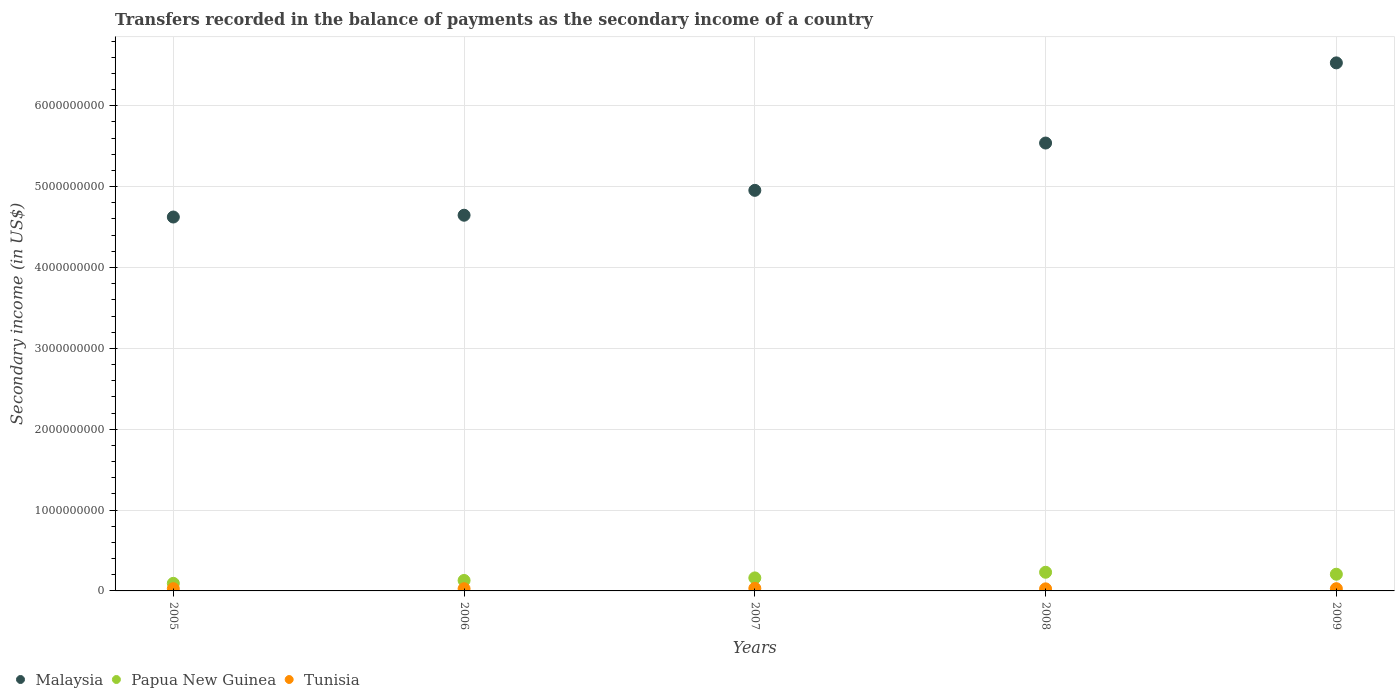How many different coloured dotlines are there?
Ensure brevity in your answer.  3. What is the secondary income of in Papua New Guinea in 2009?
Your answer should be very brief. 2.06e+08. Across all years, what is the maximum secondary income of in Malaysia?
Ensure brevity in your answer.  6.53e+09. Across all years, what is the minimum secondary income of in Malaysia?
Ensure brevity in your answer.  4.62e+09. What is the total secondary income of in Papua New Guinea in the graph?
Make the answer very short. 8.21e+08. What is the difference between the secondary income of in Papua New Guinea in 2006 and that in 2008?
Ensure brevity in your answer.  -1.01e+08. What is the difference between the secondary income of in Malaysia in 2005 and the secondary income of in Tunisia in 2009?
Your answer should be compact. 4.60e+09. What is the average secondary income of in Tunisia per year?
Your response must be concise. 2.79e+07. In the year 2005, what is the difference between the secondary income of in Malaysia and secondary income of in Papua New Guinea?
Your answer should be compact. 4.53e+09. What is the ratio of the secondary income of in Tunisia in 2005 to that in 2009?
Provide a short and direct response. 1. Is the secondary income of in Malaysia in 2006 less than that in 2008?
Give a very brief answer. Yes. Is the difference between the secondary income of in Malaysia in 2008 and 2009 greater than the difference between the secondary income of in Papua New Guinea in 2008 and 2009?
Make the answer very short. No. What is the difference between the highest and the second highest secondary income of in Malaysia?
Offer a very short reply. 9.91e+08. What is the difference between the highest and the lowest secondary income of in Tunisia?
Keep it short and to the point. 5.80e+06. Is the secondary income of in Tunisia strictly greater than the secondary income of in Malaysia over the years?
Keep it short and to the point. No. How many years are there in the graph?
Your answer should be compact. 5. Where does the legend appear in the graph?
Your answer should be very brief. Bottom left. How many legend labels are there?
Offer a terse response. 3. How are the legend labels stacked?
Provide a succinct answer. Horizontal. What is the title of the graph?
Provide a succinct answer. Transfers recorded in the balance of payments as the secondary income of a country. What is the label or title of the Y-axis?
Your response must be concise. Secondary income (in US$). What is the Secondary income (in US$) in Malaysia in 2005?
Offer a terse response. 4.62e+09. What is the Secondary income (in US$) of Papua New Guinea in 2005?
Give a very brief answer. 9.36e+07. What is the Secondary income (in US$) of Tunisia in 2005?
Offer a very short reply. 2.77e+07. What is the Secondary income (in US$) of Malaysia in 2006?
Provide a short and direct response. 4.65e+09. What is the Secondary income (in US$) of Papua New Guinea in 2006?
Offer a very short reply. 1.29e+08. What is the Secondary income (in US$) of Tunisia in 2006?
Provide a succinct answer. 2.70e+07. What is the Secondary income (in US$) of Malaysia in 2007?
Make the answer very short. 4.95e+09. What is the Secondary income (in US$) of Papua New Guinea in 2007?
Your answer should be compact. 1.61e+08. What is the Secondary income (in US$) in Tunisia in 2007?
Your answer should be very brief. 3.15e+07. What is the Secondary income (in US$) of Malaysia in 2008?
Ensure brevity in your answer.  5.54e+09. What is the Secondary income (in US$) of Papua New Guinea in 2008?
Provide a succinct answer. 2.31e+08. What is the Secondary income (in US$) of Tunisia in 2008?
Offer a terse response. 2.57e+07. What is the Secondary income (in US$) of Malaysia in 2009?
Your response must be concise. 6.53e+09. What is the Secondary income (in US$) in Papua New Guinea in 2009?
Keep it short and to the point. 2.06e+08. What is the Secondary income (in US$) in Tunisia in 2009?
Make the answer very short. 2.75e+07. Across all years, what is the maximum Secondary income (in US$) of Malaysia?
Your answer should be compact. 6.53e+09. Across all years, what is the maximum Secondary income (in US$) in Papua New Guinea?
Provide a short and direct response. 2.31e+08. Across all years, what is the maximum Secondary income (in US$) in Tunisia?
Provide a succinct answer. 3.15e+07. Across all years, what is the minimum Secondary income (in US$) in Malaysia?
Offer a very short reply. 4.62e+09. Across all years, what is the minimum Secondary income (in US$) of Papua New Guinea?
Your answer should be very brief. 9.36e+07. Across all years, what is the minimum Secondary income (in US$) in Tunisia?
Your response must be concise. 2.57e+07. What is the total Secondary income (in US$) of Malaysia in the graph?
Keep it short and to the point. 2.63e+1. What is the total Secondary income (in US$) in Papua New Guinea in the graph?
Ensure brevity in your answer.  8.21e+08. What is the total Secondary income (in US$) in Tunisia in the graph?
Give a very brief answer. 1.40e+08. What is the difference between the Secondary income (in US$) of Malaysia in 2005 and that in 2006?
Keep it short and to the point. -2.22e+07. What is the difference between the Secondary income (in US$) in Papua New Guinea in 2005 and that in 2006?
Offer a very short reply. -3.58e+07. What is the difference between the Secondary income (in US$) of Tunisia in 2005 and that in 2006?
Keep it short and to the point. 6.23e+05. What is the difference between the Secondary income (in US$) of Malaysia in 2005 and that in 2007?
Provide a succinct answer. -3.30e+08. What is the difference between the Secondary income (in US$) of Papua New Guinea in 2005 and that in 2007?
Provide a succinct answer. -6.73e+07. What is the difference between the Secondary income (in US$) in Tunisia in 2005 and that in 2007?
Make the answer very short. -3.86e+06. What is the difference between the Secondary income (in US$) of Malaysia in 2005 and that in 2008?
Ensure brevity in your answer.  -9.15e+08. What is the difference between the Secondary income (in US$) of Papua New Guinea in 2005 and that in 2008?
Your response must be concise. -1.37e+08. What is the difference between the Secondary income (in US$) in Tunisia in 2005 and that in 2008?
Make the answer very short. 1.94e+06. What is the difference between the Secondary income (in US$) of Malaysia in 2005 and that in 2009?
Your answer should be very brief. -1.91e+09. What is the difference between the Secondary income (in US$) of Papua New Guinea in 2005 and that in 2009?
Keep it short and to the point. -1.13e+08. What is the difference between the Secondary income (in US$) in Tunisia in 2005 and that in 2009?
Your answer should be very brief. 1.20e+05. What is the difference between the Secondary income (in US$) of Malaysia in 2006 and that in 2007?
Offer a very short reply. -3.08e+08. What is the difference between the Secondary income (in US$) of Papua New Guinea in 2006 and that in 2007?
Keep it short and to the point. -3.15e+07. What is the difference between the Secondary income (in US$) in Tunisia in 2006 and that in 2007?
Keep it short and to the point. -4.48e+06. What is the difference between the Secondary income (in US$) in Malaysia in 2006 and that in 2008?
Keep it short and to the point. -8.93e+08. What is the difference between the Secondary income (in US$) of Papua New Guinea in 2006 and that in 2008?
Your answer should be very brief. -1.01e+08. What is the difference between the Secondary income (in US$) of Tunisia in 2006 and that in 2008?
Provide a succinct answer. 1.32e+06. What is the difference between the Secondary income (in US$) in Malaysia in 2006 and that in 2009?
Offer a terse response. -1.88e+09. What is the difference between the Secondary income (in US$) of Papua New Guinea in 2006 and that in 2009?
Offer a terse response. -7.71e+07. What is the difference between the Secondary income (in US$) in Tunisia in 2006 and that in 2009?
Ensure brevity in your answer.  -5.03e+05. What is the difference between the Secondary income (in US$) of Malaysia in 2007 and that in 2008?
Keep it short and to the point. -5.85e+08. What is the difference between the Secondary income (in US$) in Papua New Guinea in 2007 and that in 2008?
Your answer should be very brief. -7.00e+07. What is the difference between the Secondary income (in US$) of Tunisia in 2007 and that in 2008?
Your answer should be compact. 5.80e+06. What is the difference between the Secondary income (in US$) in Malaysia in 2007 and that in 2009?
Keep it short and to the point. -1.58e+09. What is the difference between the Secondary income (in US$) of Papua New Guinea in 2007 and that in 2009?
Give a very brief answer. -4.56e+07. What is the difference between the Secondary income (in US$) of Tunisia in 2007 and that in 2009?
Give a very brief answer. 3.98e+06. What is the difference between the Secondary income (in US$) of Malaysia in 2008 and that in 2009?
Provide a succinct answer. -9.91e+08. What is the difference between the Secondary income (in US$) of Papua New Guinea in 2008 and that in 2009?
Offer a very short reply. 2.44e+07. What is the difference between the Secondary income (in US$) of Tunisia in 2008 and that in 2009?
Your answer should be compact. -1.82e+06. What is the difference between the Secondary income (in US$) in Malaysia in 2005 and the Secondary income (in US$) in Papua New Guinea in 2006?
Keep it short and to the point. 4.49e+09. What is the difference between the Secondary income (in US$) in Malaysia in 2005 and the Secondary income (in US$) in Tunisia in 2006?
Offer a terse response. 4.60e+09. What is the difference between the Secondary income (in US$) in Papua New Guinea in 2005 and the Secondary income (in US$) in Tunisia in 2006?
Offer a very short reply. 6.65e+07. What is the difference between the Secondary income (in US$) in Malaysia in 2005 and the Secondary income (in US$) in Papua New Guinea in 2007?
Offer a very short reply. 4.46e+09. What is the difference between the Secondary income (in US$) of Malaysia in 2005 and the Secondary income (in US$) of Tunisia in 2007?
Keep it short and to the point. 4.59e+09. What is the difference between the Secondary income (in US$) in Papua New Guinea in 2005 and the Secondary income (in US$) in Tunisia in 2007?
Offer a terse response. 6.21e+07. What is the difference between the Secondary income (in US$) in Malaysia in 2005 and the Secondary income (in US$) in Papua New Guinea in 2008?
Offer a very short reply. 4.39e+09. What is the difference between the Secondary income (in US$) in Malaysia in 2005 and the Secondary income (in US$) in Tunisia in 2008?
Offer a very short reply. 4.60e+09. What is the difference between the Secondary income (in US$) in Papua New Guinea in 2005 and the Secondary income (in US$) in Tunisia in 2008?
Give a very brief answer. 6.79e+07. What is the difference between the Secondary income (in US$) in Malaysia in 2005 and the Secondary income (in US$) in Papua New Guinea in 2009?
Your answer should be compact. 4.42e+09. What is the difference between the Secondary income (in US$) of Malaysia in 2005 and the Secondary income (in US$) of Tunisia in 2009?
Your answer should be very brief. 4.60e+09. What is the difference between the Secondary income (in US$) of Papua New Guinea in 2005 and the Secondary income (in US$) of Tunisia in 2009?
Offer a terse response. 6.60e+07. What is the difference between the Secondary income (in US$) of Malaysia in 2006 and the Secondary income (in US$) of Papua New Guinea in 2007?
Give a very brief answer. 4.49e+09. What is the difference between the Secondary income (in US$) in Malaysia in 2006 and the Secondary income (in US$) in Tunisia in 2007?
Give a very brief answer. 4.61e+09. What is the difference between the Secondary income (in US$) of Papua New Guinea in 2006 and the Secondary income (in US$) of Tunisia in 2007?
Offer a terse response. 9.79e+07. What is the difference between the Secondary income (in US$) in Malaysia in 2006 and the Secondary income (in US$) in Papua New Guinea in 2008?
Provide a short and direct response. 4.42e+09. What is the difference between the Secondary income (in US$) in Malaysia in 2006 and the Secondary income (in US$) in Tunisia in 2008?
Offer a terse response. 4.62e+09. What is the difference between the Secondary income (in US$) in Papua New Guinea in 2006 and the Secondary income (in US$) in Tunisia in 2008?
Keep it short and to the point. 1.04e+08. What is the difference between the Secondary income (in US$) in Malaysia in 2006 and the Secondary income (in US$) in Papua New Guinea in 2009?
Your answer should be very brief. 4.44e+09. What is the difference between the Secondary income (in US$) in Malaysia in 2006 and the Secondary income (in US$) in Tunisia in 2009?
Your answer should be compact. 4.62e+09. What is the difference between the Secondary income (in US$) in Papua New Guinea in 2006 and the Secondary income (in US$) in Tunisia in 2009?
Ensure brevity in your answer.  1.02e+08. What is the difference between the Secondary income (in US$) in Malaysia in 2007 and the Secondary income (in US$) in Papua New Guinea in 2008?
Provide a short and direct response. 4.72e+09. What is the difference between the Secondary income (in US$) in Malaysia in 2007 and the Secondary income (in US$) in Tunisia in 2008?
Offer a terse response. 4.93e+09. What is the difference between the Secondary income (in US$) in Papua New Guinea in 2007 and the Secondary income (in US$) in Tunisia in 2008?
Provide a short and direct response. 1.35e+08. What is the difference between the Secondary income (in US$) of Malaysia in 2007 and the Secondary income (in US$) of Papua New Guinea in 2009?
Your answer should be compact. 4.75e+09. What is the difference between the Secondary income (in US$) of Malaysia in 2007 and the Secondary income (in US$) of Tunisia in 2009?
Provide a short and direct response. 4.93e+09. What is the difference between the Secondary income (in US$) in Papua New Guinea in 2007 and the Secondary income (in US$) in Tunisia in 2009?
Keep it short and to the point. 1.33e+08. What is the difference between the Secondary income (in US$) of Malaysia in 2008 and the Secondary income (in US$) of Papua New Guinea in 2009?
Provide a short and direct response. 5.33e+09. What is the difference between the Secondary income (in US$) in Malaysia in 2008 and the Secondary income (in US$) in Tunisia in 2009?
Your answer should be compact. 5.51e+09. What is the difference between the Secondary income (in US$) in Papua New Guinea in 2008 and the Secondary income (in US$) in Tunisia in 2009?
Ensure brevity in your answer.  2.03e+08. What is the average Secondary income (in US$) in Malaysia per year?
Ensure brevity in your answer.  5.26e+09. What is the average Secondary income (in US$) in Papua New Guinea per year?
Your response must be concise. 1.64e+08. What is the average Secondary income (in US$) of Tunisia per year?
Offer a terse response. 2.79e+07. In the year 2005, what is the difference between the Secondary income (in US$) of Malaysia and Secondary income (in US$) of Papua New Guinea?
Offer a terse response. 4.53e+09. In the year 2005, what is the difference between the Secondary income (in US$) in Malaysia and Secondary income (in US$) in Tunisia?
Your answer should be very brief. 4.60e+09. In the year 2005, what is the difference between the Secondary income (in US$) in Papua New Guinea and Secondary income (in US$) in Tunisia?
Your answer should be very brief. 6.59e+07. In the year 2006, what is the difference between the Secondary income (in US$) in Malaysia and Secondary income (in US$) in Papua New Guinea?
Ensure brevity in your answer.  4.52e+09. In the year 2006, what is the difference between the Secondary income (in US$) of Malaysia and Secondary income (in US$) of Tunisia?
Your response must be concise. 4.62e+09. In the year 2006, what is the difference between the Secondary income (in US$) in Papua New Guinea and Secondary income (in US$) in Tunisia?
Give a very brief answer. 1.02e+08. In the year 2007, what is the difference between the Secondary income (in US$) in Malaysia and Secondary income (in US$) in Papua New Guinea?
Keep it short and to the point. 4.79e+09. In the year 2007, what is the difference between the Secondary income (in US$) of Malaysia and Secondary income (in US$) of Tunisia?
Provide a succinct answer. 4.92e+09. In the year 2007, what is the difference between the Secondary income (in US$) of Papua New Guinea and Secondary income (in US$) of Tunisia?
Offer a very short reply. 1.29e+08. In the year 2008, what is the difference between the Secondary income (in US$) of Malaysia and Secondary income (in US$) of Papua New Guinea?
Your answer should be very brief. 5.31e+09. In the year 2008, what is the difference between the Secondary income (in US$) of Malaysia and Secondary income (in US$) of Tunisia?
Ensure brevity in your answer.  5.51e+09. In the year 2008, what is the difference between the Secondary income (in US$) in Papua New Guinea and Secondary income (in US$) in Tunisia?
Keep it short and to the point. 2.05e+08. In the year 2009, what is the difference between the Secondary income (in US$) of Malaysia and Secondary income (in US$) of Papua New Guinea?
Your response must be concise. 6.32e+09. In the year 2009, what is the difference between the Secondary income (in US$) in Malaysia and Secondary income (in US$) in Tunisia?
Your answer should be compact. 6.50e+09. In the year 2009, what is the difference between the Secondary income (in US$) in Papua New Guinea and Secondary income (in US$) in Tunisia?
Your answer should be compact. 1.79e+08. What is the ratio of the Secondary income (in US$) of Papua New Guinea in 2005 to that in 2006?
Make the answer very short. 0.72. What is the ratio of the Secondary income (in US$) in Malaysia in 2005 to that in 2007?
Ensure brevity in your answer.  0.93. What is the ratio of the Secondary income (in US$) of Papua New Guinea in 2005 to that in 2007?
Offer a very short reply. 0.58. What is the ratio of the Secondary income (in US$) of Tunisia in 2005 to that in 2007?
Your response must be concise. 0.88. What is the ratio of the Secondary income (in US$) of Malaysia in 2005 to that in 2008?
Offer a terse response. 0.83. What is the ratio of the Secondary income (in US$) of Papua New Guinea in 2005 to that in 2008?
Make the answer very short. 0.41. What is the ratio of the Secondary income (in US$) of Tunisia in 2005 to that in 2008?
Offer a very short reply. 1.08. What is the ratio of the Secondary income (in US$) of Malaysia in 2005 to that in 2009?
Provide a short and direct response. 0.71. What is the ratio of the Secondary income (in US$) of Papua New Guinea in 2005 to that in 2009?
Ensure brevity in your answer.  0.45. What is the ratio of the Secondary income (in US$) of Tunisia in 2005 to that in 2009?
Keep it short and to the point. 1. What is the ratio of the Secondary income (in US$) of Malaysia in 2006 to that in 2007?
Keep it short and to the point. 0.94. What is the ratio of the Secondary income (in US$) in Papua New Guinea in 2006 to that in 2007?
Give a very brief answer. 0.8. What is the ratio of the Secondary income (in US$) in Tunisia in 2006 to that in 2007?
Give a very brief answer. 0.86. What is the ratio of the Secondary income (in US$) in Malaysia in 2006 to that in 2008?
Offer a terse response. 0.84. What is the ratio of the Secondary income (in US$) of Papua New Guinea in 2006 to that in 2008?
Your response must be concise. 0.56. What is the ratio of the Secondary income (in US$) of Tunisia in 2006 to that in 2008?
Your answer should be very brief. 1.05. What is the ratio of the Secondary income (in US$) in Malaysia in 2006 to that in 2009?
Give a very brief answer. 0.71. What is the ratio of the Secondary income (in US$) of Papua New Guinea in 2006 to that in 2009?
Make the answer very short. 0.63. What is the ratio of the Secondary income (in US$) in Tunisia in 2006 to that in 2009?
Ensure brevity in your answer.  0.98. What is the ratio of the Secondary income (in US$) of Malaysia in 2007 to that in 2008?
Make the answer very short. 0.89. What is the ratio of the Secondary income (in US$) of Papua New Guinea in 2007 to that in 2008?
Your answer should be compact. 0.7. What is the ratio of the Secondary income (in US$) of Tunisia in 2007 to that in 2008?
Ensure brevity in your answer.  1.23. What is the ratio of the Secondary income (in US$) of Malaysia in 2007 to that in 2009?
Make the answer very short. 0.76. What is the ratio of the Secondary income (in US$) in Papua New Guinea in 2007 to that in 2009?
Offer a very short reply. 0.78. What is the ratio of the Secondary income (in US$) of Tunisia in 2007 to that in 2009?
Your answer should be very brief. 1.14. What is the ratio of the Secondary income (in US$) of Malaysia in 2008 to that in 2009?
Your response must be concise. 0.85. What is the ratio of the Secondary income (in US$) of Papua New Guinea in 2008 to that in 2009?
Offer a terse response. 1.12. What is the ratio of the Secondary income (in US$) in Tunisia in 2008 to that in 2009?
Your answer should be compact. 0.93. What is the difference between the highest and the second highest Secondary income (in US$) in Malaysia?
Keep it short and to the point. 9.91e+08. What is the difference between the highest and the second highest Secondary income (in US$) in Papua New Guinea?
Offer a terse response. 2.44e+07. What is the difference between the highest and the second highest Secondary income (in US$) in Tunisia?
Keep it short and to the point. 3.86e+06. What is the difference between the highest and the lowest Secondary income (in US$) in Malaysia?
Your answer should be compact. 1.91e+09. What is the difference between the highest and the lowest Secondary income (in US$) of Papua New Guinea?
Your response must be concise. 1.37e+08. What is the difference between the highest and the lowest Secondary income (in US$) of Tunisia?
Keep it short and to the point. 5.80e+06. 